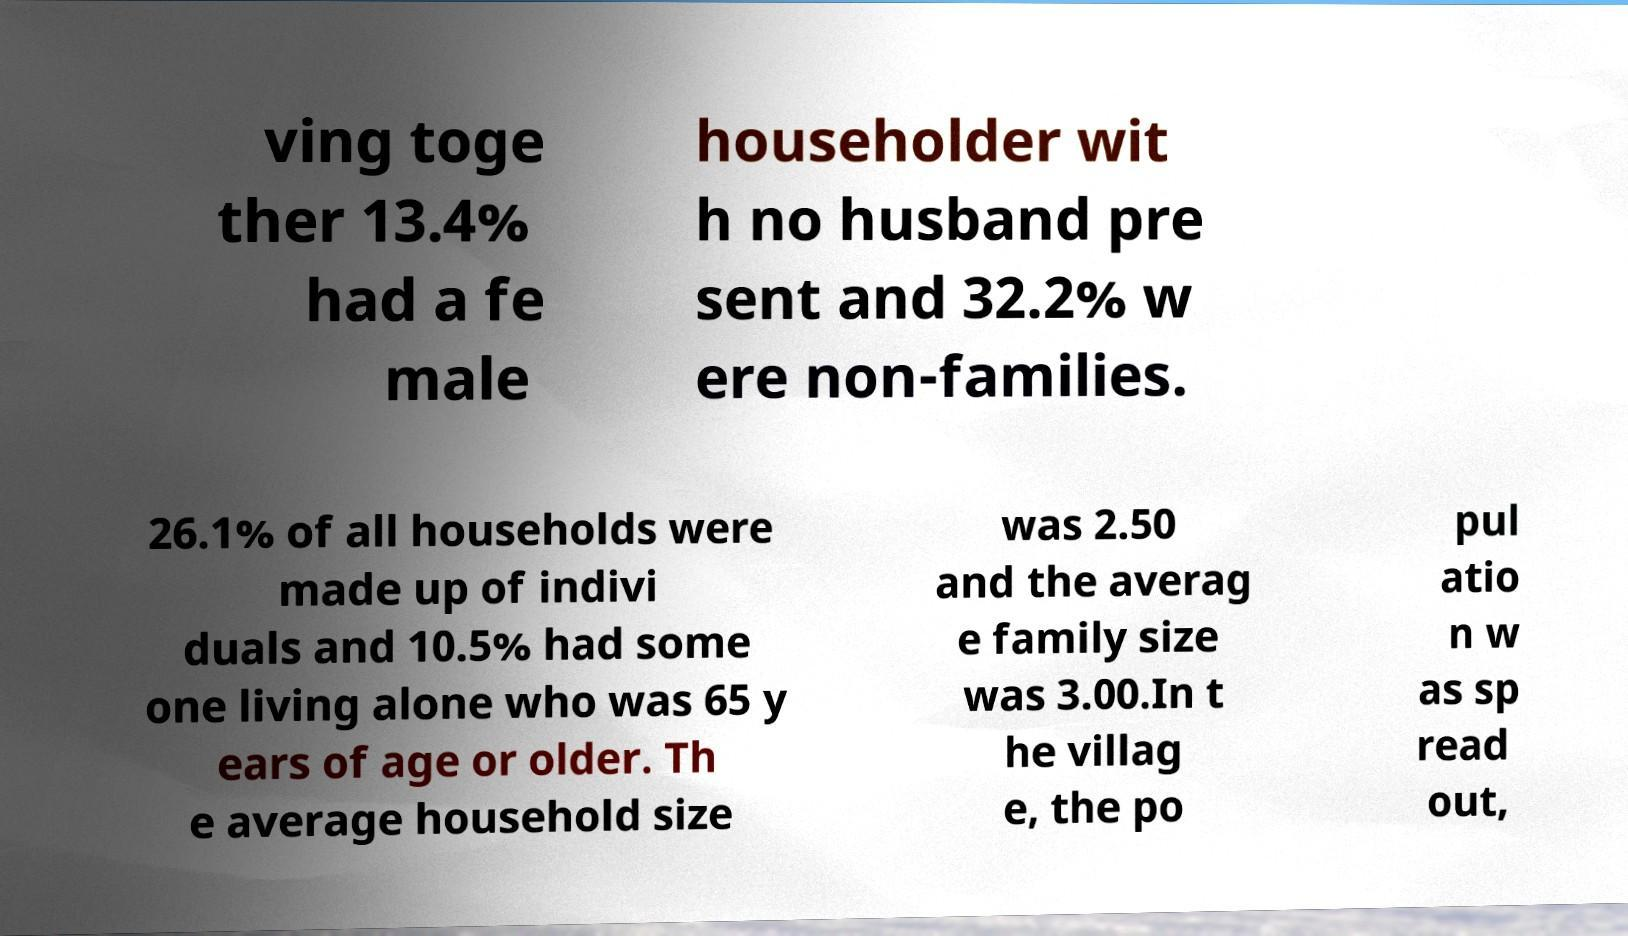There's text embedded in this image that I need extracted. Can you transcribe it verbatim? ving toge ther 13.4% had a fe male householder wit h no husband pre sent and 32.2% w ere non-families. 26.1% of all households were made up of indivi duals and 10.5% had some one living alone who was 65 y ears of age or older. Th e average household size was 2.50 and the averag e family size was 3.00.In t he villag e, the po pul atio n w as sp read out, 